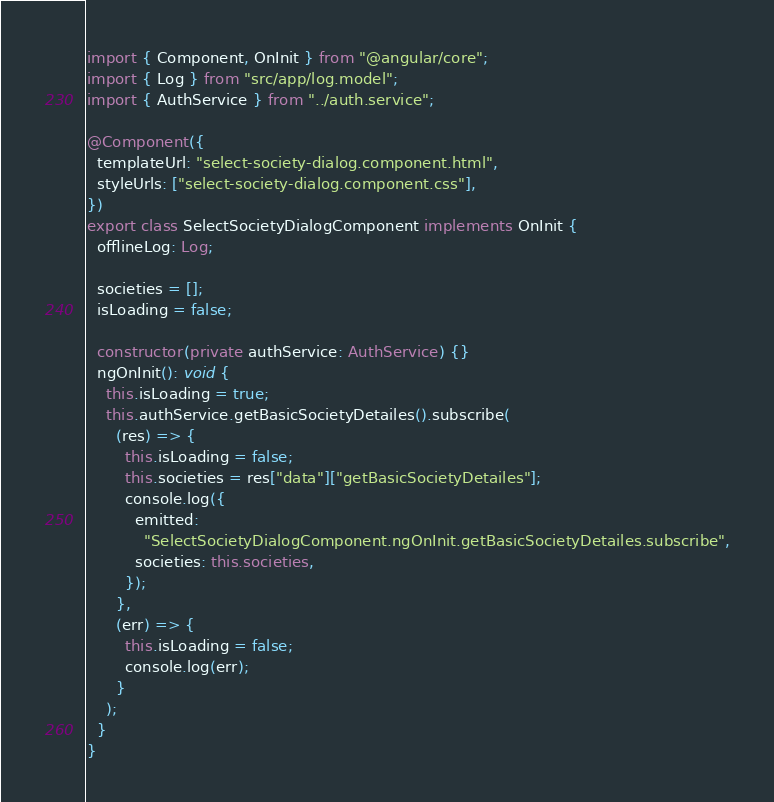<code> <loc_0><loc_0><loc_500><loc_500><_TypeScript_>import { Component, OnInit } from "@angular/core";
import { Log } from "src/app/log.model";
import { AuthService } from "../auth.service";

@Component({
  templateUrl: "select-society-dialog.component.html",
  styleUrls: ["select-society-dialog.component.css"],
})
export class SelectSocietyDialogComponent implements OnInit {
  offlineLog: Log;

  societies = [];
  isLoading = false;

  constructor(private authService: AuthService) {}
  ngOnInit(): void {
    this.isLoading = true;
    this.authService.getBasicSocietyDetailes().subscribe(
      (res) => {
        this.isLoading = false;
        this.societies = res["data"]["getBasicSocietyDetailes"];
        console.log({
          emitted:
            "SelectSocietyDialogComponent.ngOnInit.getBasicSocietyDetailes.subscribe",
          societies: this.societies,
        });
      },
      (err) => {
        this.isLoading = false;
        console.log(err);
      }
    );
  }
}
</code> 